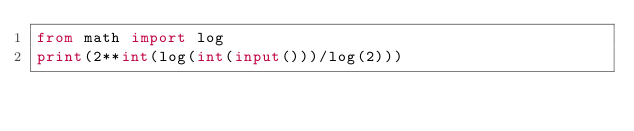Convert code to text. <code><loc_0><loc_0><loc_500><loc_500><_Python_>from math import log
print(2**int(log(int(input()))/log(2)))</code> 